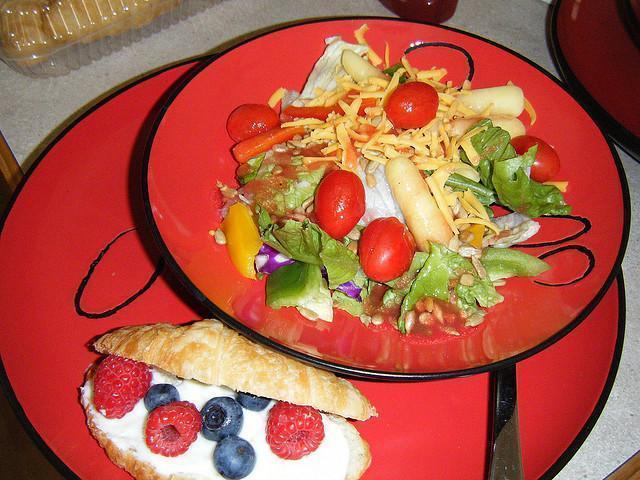How many items qualify as a berry botanically?
Select the accurate response from the four choices given to answer the question.
Options: Two, three, one, four. Two. 